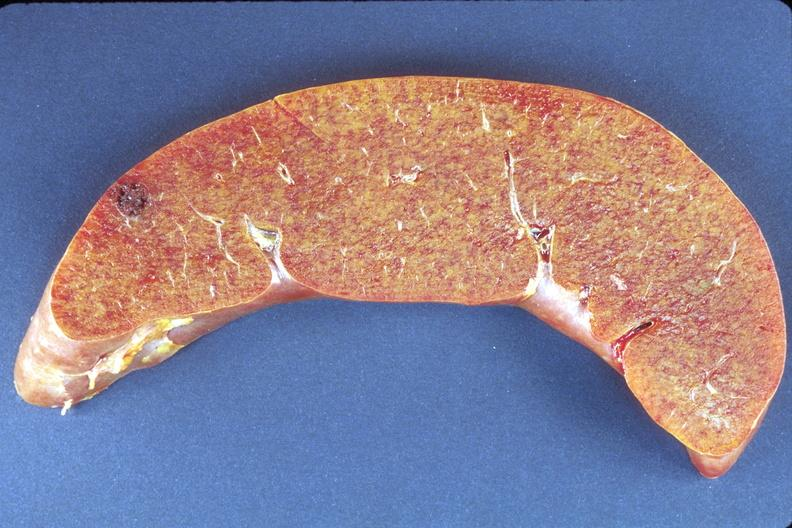s pituitectomy present?
Answer the question using a single word or phrase. No 